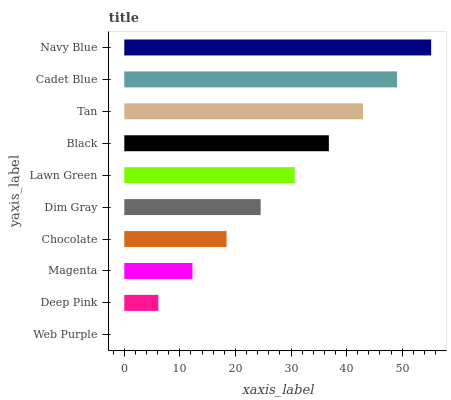Is Web Purple the minimum?
Answer yes or no. Yes. Is Navy Blue the maximum?
Answer yes or no. Yes. Is Deep Pink the minimum?
Answer yes or no. No. Is Deep Pink the maximum?
Answer yes or no. No. Is Deep Pink greater than Web Purple?
Answer yes or no. Yes. Is Web Purple less than Deep Pink?
Answer yes or no. Yes. Is Web Purple greater than Deep Pink?
Answer yes or no. No. Is Deep Pink less than Web Purple?
Answer yes or no. No. Is Lawn Green the high median?
Answer yes or no. Yes. Is Dim Gray the low median?
Answer yes or no. Yes. Is Chocolate the high median?
Answer yes or no. No. Is Tan the low median?
Answer yes or no. No. 